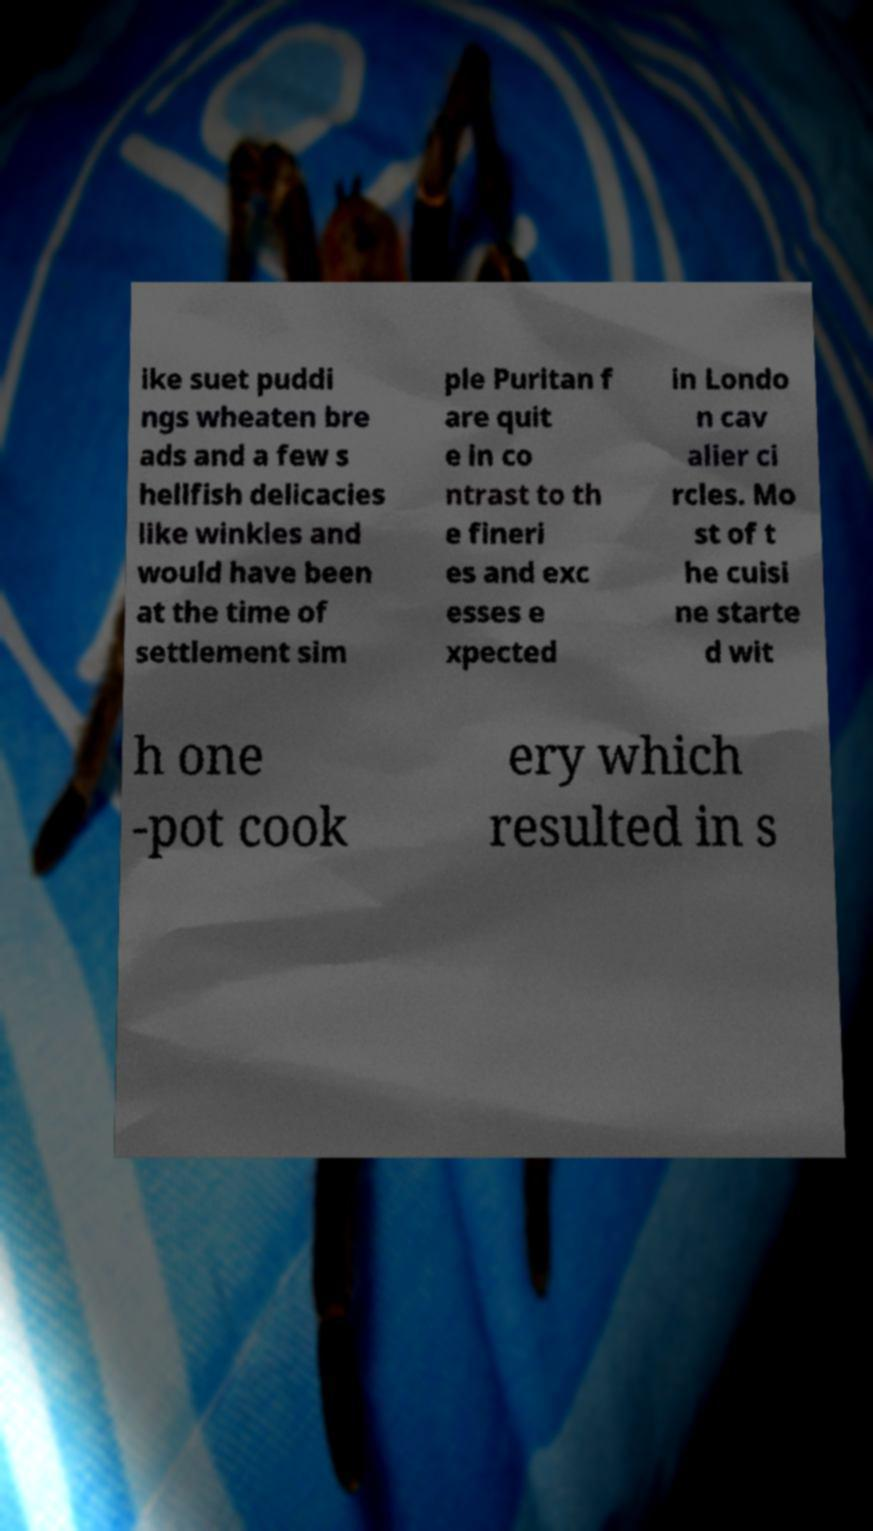What messages or text are displayed in this image? I need them in a readable, typed format. ike suet puddi ngs wheaten bre ads and a few s hellfish delicacies like winkles and would have been at the time of settlement sim ple Puritan f are quit e in co ntrast to th e fineri es and exc esses e xpected in Londo n cav alier ci rcles. Mo st of t he cuisi ne starte d wit h one -pot cook ery which resulted in s 